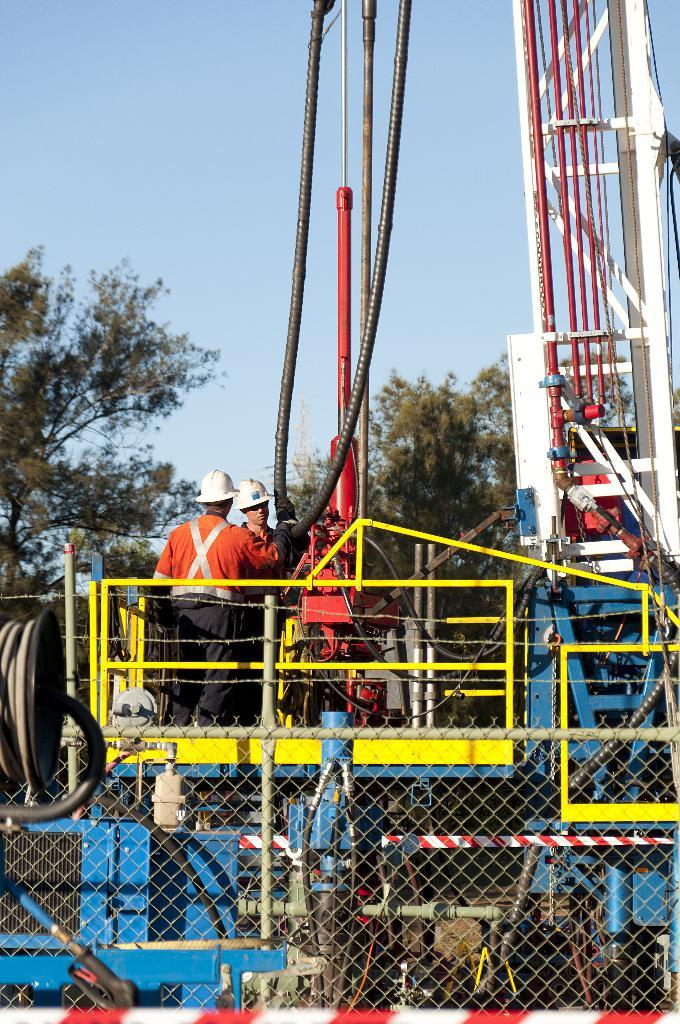What type of fencing is visible in the image? There is a mesh fencing in the image. What can be seen near the fencing? There is a machine with pipes and rods in the image. Who is near the machine? Two people are standing near the machine. What are the people wearing? The people are wearing helmets. What is visible in the background of the image? There are trees and the sky in the background of the image. What type of bun is being held by one of the people in the image? There is no bun present in the image; the people are wearing helmets. Can you tell me how many hearts are visible in the image? There are no hearts visible in the image. 